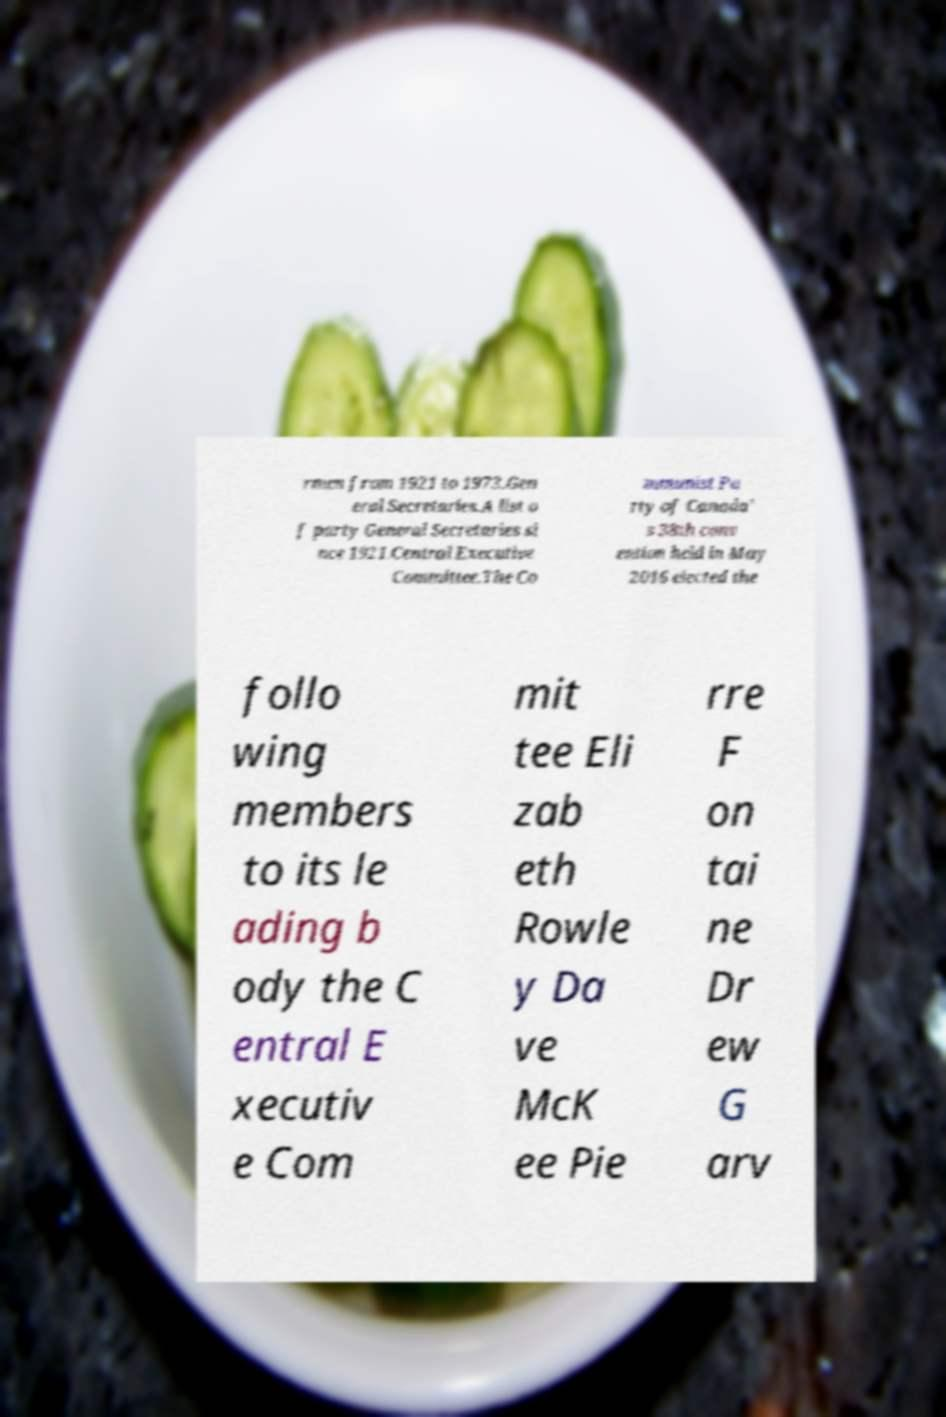For documentation purposes, I need the text within this image transcribed. Could you provide that? rmen from 1921 to 1973.Gen eral Secretaries.A list o f party General Secretaries si nce 1921.Central Executive Committee.The Co mmunist Pa rty of Canada' s 38th conv ention held in May 2016 elected the follo wing members to its le ading b ody the C entral E xecutiv e Com mit tee Eli zab eth Rowle y Da ve McK ee Pie rre F on tai ne Dr ew G arv 